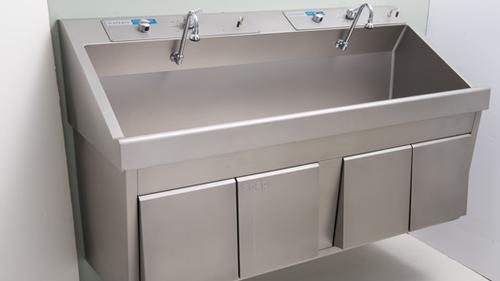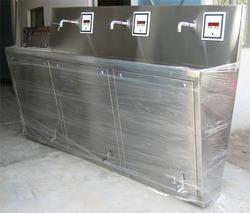The first image is the image on the left, the second image is the image on the right. Analyze the images presented: Is the assertion "There are exactly five faucets." valid? Answer yes or no. Yes. 